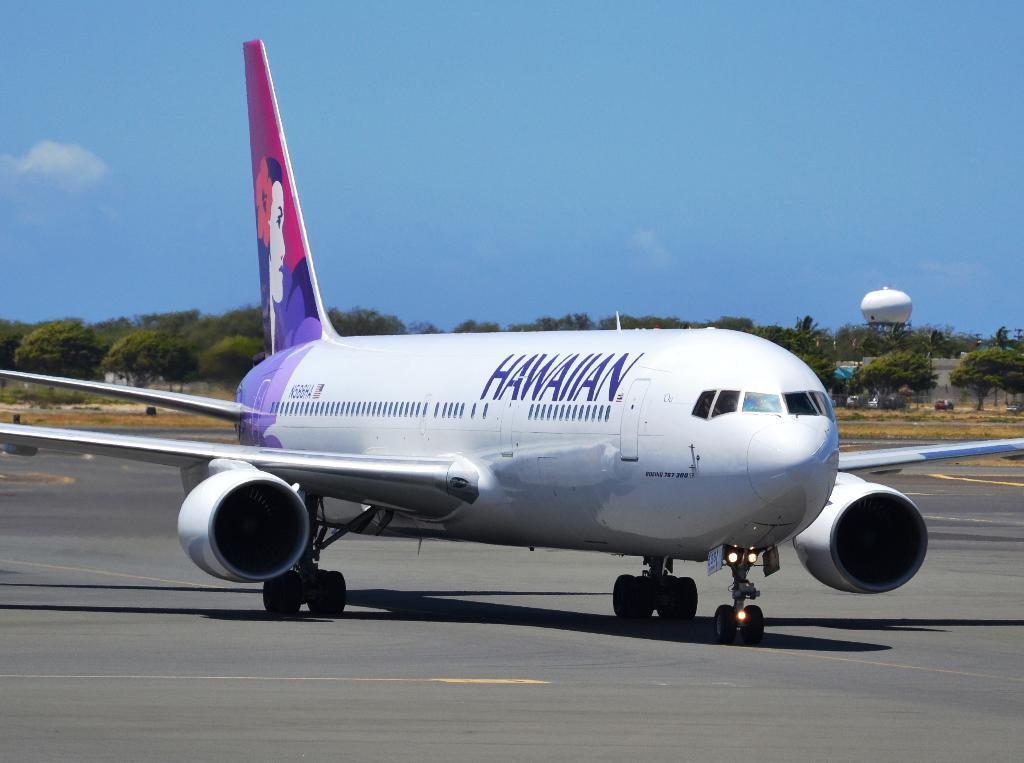<image>
Create a compact narrative representing the image presented. The Hawaiian Air plane features a woman with a flower on the tail piece. 